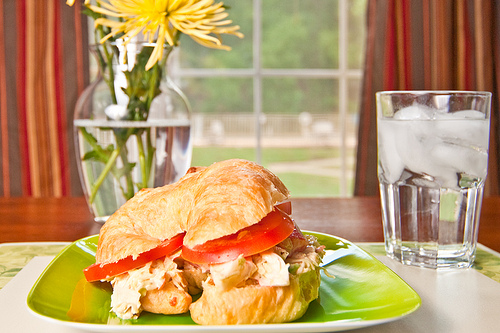Can you describe the scene in the image? The image depicts a bright, cozy setting with a croissant sandwich on a green plate, positioned in front of a window. The sandwich appears to be filled with chicken and tomatoes. To the left, there's a vase with beautiful yellow flowers, and to the right, a glass of water with ice sits on a table. In the background, the outside greenery enhances the serene atmosphere. 